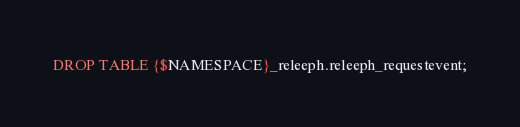<code> <loc_0><loc_0><loc_500><loc_500><_SQL_>DROP TABLE {$NAMESPACE}_releeph.releeph_requestevent;
</code> 